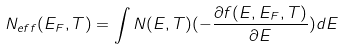Convert formula to latex. <formula><loc_0><loc_0><loc_500><loc_500>N _ { e f f } ( E _ { F } , T ) = \int N ( E , T ) ( - \frac { \partial f ( E , E _ { F } , T ) } { \partial E } ) d E</formula> 